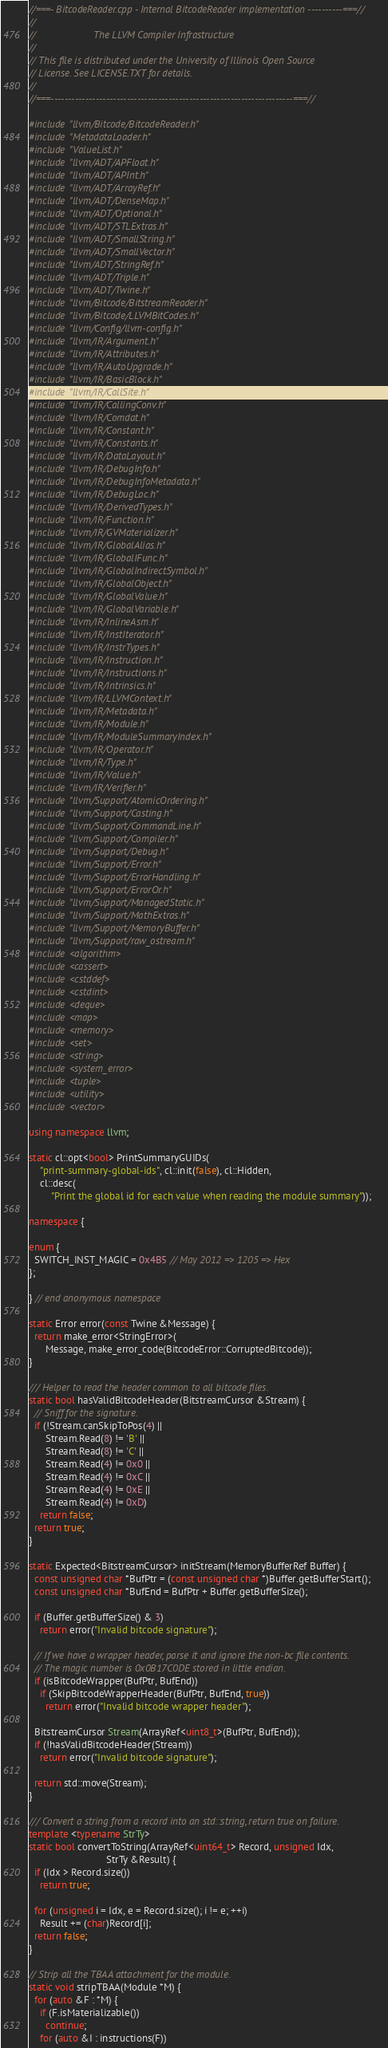Convert code to text. <code><loc_0><loc_0><loc_500><loc_500><_C++_>//===- BitcodeReader.cpp - Internal BitcodeReader implementation ----------===//
//
//                     The LLVM Compiler Infrastructure
//
// This file is distributed under the University of Illinois Open Source
// License. See LICENSE.TXT for details.
//
//===----------------------------------------------------------------------===//

#include "llvm/Bitcode/BitcodeReader.h"
#include "MetadataLoader.h"
#include "ValueList.h"
#include "llvm/ADT/APFloat.h"
#include "llvm/ADT/APInt.h"
#include "llvm/ADT/ArrayRef.h"
#include "llvm/ADT/DenseMap.h"
#include "llvm/ADT/Optional.h"
#include "llvm/ADT/STLExtras.h"
#include "llvm/ADT/SmallString.h"
#include "llvm/ADT/SmallVector.h"
#include "llvm/ADT/StringRef.h"
#include "llvm/ADT/Triple.h"
#include "llvm/ADT/Twine.h"
#include "llvm/Bitcode/BitstreamReader.h"
#include "llvm/Bitcode/LLVMBitCodes.h"
#include "llvm/Config/llvm-config.h"
#include "llvm/IR/Argument.h"
#include "llvm/IR/Attributes.h"
#include "llvm/IR/AutoUpgrade.h"
#include "llvm/IR/BasicBlock.h"
#include "llvm/IR/CallSite.h"
#include "llvm/IR/CallingConv.h"
#include "llvm/IR/Comdat.h"
#include "llvm/IR/Constant.h"
#include "llvm/IR/Constants.h"
#include "llvm/IR/DataLayout.h"
#include "llvm/IR/DebugInfo.h"
#include "llvm/IR/DebugInfoMetadata.h"
#include "llvm/IR/DebugLoc.h"
#include "llvm/IR/DerivedTypes.h"
#include "llvm/IR/Function.h"
#include "llvm/IR/GVMaterializer.h"
#include "llvm/IR/GlobalAlias.h"
#include "llvm/IR/GlobalIFunc.h"
#include "llvm/IR/GlobalIndirectSymbol.h"
#include "llvm/IR/GlobalObject.h"
#include "llvm/IR/GlobalValue.h"
#include "llvm/IR/GlobalVariable.h"
#include "llvm/IR/InlineAsm.h"
#include "llvm/IR/InstIterator.h"
#include "llvm/IR/InstrTypes.h"
#include "llvm/IR/Instruction.h"
#include "llvm/IR/Instructions.h"
#include "llvm/IR/Intrinsics.h"
#include "llvm/IR/LLVMContext.h"
#include "llvm/IR/Metadata.h"
#include "llvm/IR/Module.h"
#include "llvm/IR/ModuleSummaryIndex.h"
#include "llvm/IR/Operator.h"
#include "llvm/IR/Type.h"
#include "llvm/IR/Value.h"
#include "llvm/IR/Verifier.h"
#include "llvm/Support/AtomicOrdering.h"
#include "llvm/Support/Casting.h"
#include "llvm/Support/CommandLine.h"
#include "llvm/Support/Compiler.h"
#include "llvm/Support/Debug.h"
#include "llvm/Support/Error.h"
#include "llvm/Support/ErrorHandling.h"
#include "llvm/Support/ErrorOr.h"
#include "llvm/Support/ManagedStatic.h"
#include "llvm/Support/MathExtras.h"
#include "llvm/Support/MemoryBuffer.h"
#include "llvm/Support/raw_ostream.h"
#include <algorithm>
#include <cassert>
#include <cstddef>
#include <cstdint>
#include <deque>
#include <map>
#include <memory>
#include <set>
#include <string>
#include <system_error>
#include <tuple>
#include <utility>
#include <vector>

using namespace llvm;

static cl::opt<bool> PrintSummaryGUIDs(
    "print-summary-global-ids", cl::init(false), cl::Hidden,
    cl::desc(
        "Print the global id for each value when reading the module summary"));

namespace {

enum {
  SWITCH_INST_MAGIC = 0x4B5 // May 2012 => 1205 => Hex
};

} // end anonymous namespace

static Error error(const Twine &Message) {
  return make_error<StringError>(
      Message, make_error_code(BitcodeError::CorruptedBitcode));
}

/// Helper to read the header common to all bitcode files.
static bool hasValidBitcodeHeader(BitstreamCursor &Stream) {
  // Sniff for the signature.
  if (!Stream.canSkipToPos(4) ||
      Stream.Read(8) != 'B' ||
      Stream.Read(8) != 'C' ||
      Stream.Read(4) != 0x0 ||
      Stream.Read(4) != 0xC ||
      Stream.Read(4) != 0xE ||
      Stream.Read(4) != 0xD)
    return false;
  return true;
}

static Expected<BitstreamCursor> initStream(MemoryBufferRef Buffer) {
  const unsigned char *BufPtr = (const unsigned char *)Buffer.getBufferStart();
  const unsigned char *BufEnd = BufPtr + Buffer.getBufferSize();

  if (Buffer.getBufferSize() & 3)
    return error("Invalid bitcode signature");

  // If we have a wrapper header, parse it and ignore the non-bc file contents.
  // The magic number is 0x0B17C0DE stored in little endian.
  if (isBitcodeWrapper(BufPtr, BufEnd))
    if (SkipBitcodeWrapperHeader(BufPtr, BufEnd, true))
      return error("Invalid bitcode wrapper header");

  BitstreamCursor Stream(ArrayRef<uint8_t>(BufPtr, BufEnd));
  if (!hasValidBitcodeHeader(Stream))
    return error("Invalid bitcode signature");

  return std::move(Stream);
}

/// Convert a string from a record into an std::string, return true on failure.
template <typename StrTy>
static bool convertToString(ArrayRef<uint64_t> Record, unsigned Idx,
                            StrTy &Result) {
  if (Idx > Record.size())
    return true;

  for (unsigned i = Idx, e = Record.size(); i != e; ++i)
    Result += (char)Record[i];
  return false;
}

// Strip all the TBAA attachment for the module.
static void stripTBAA(Module *M) {
  for (auto &F : *M) {
    if (F.isMaterializable())
      continue;
    for (auto &I : instructions(F))</code> 